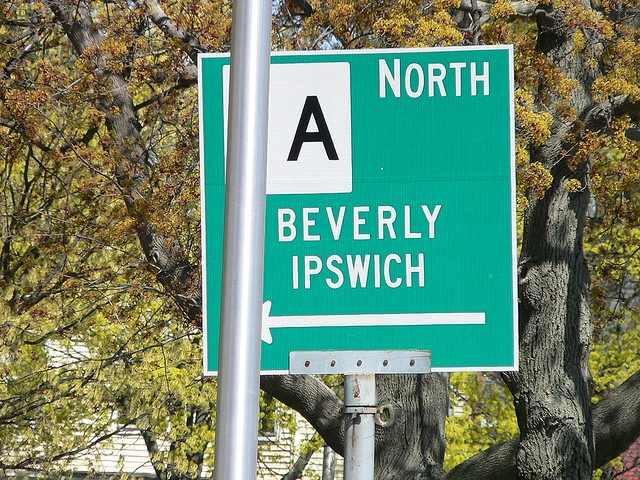Describe the objects in this image and their specific colors. I can see various objects in this image with different colors. 